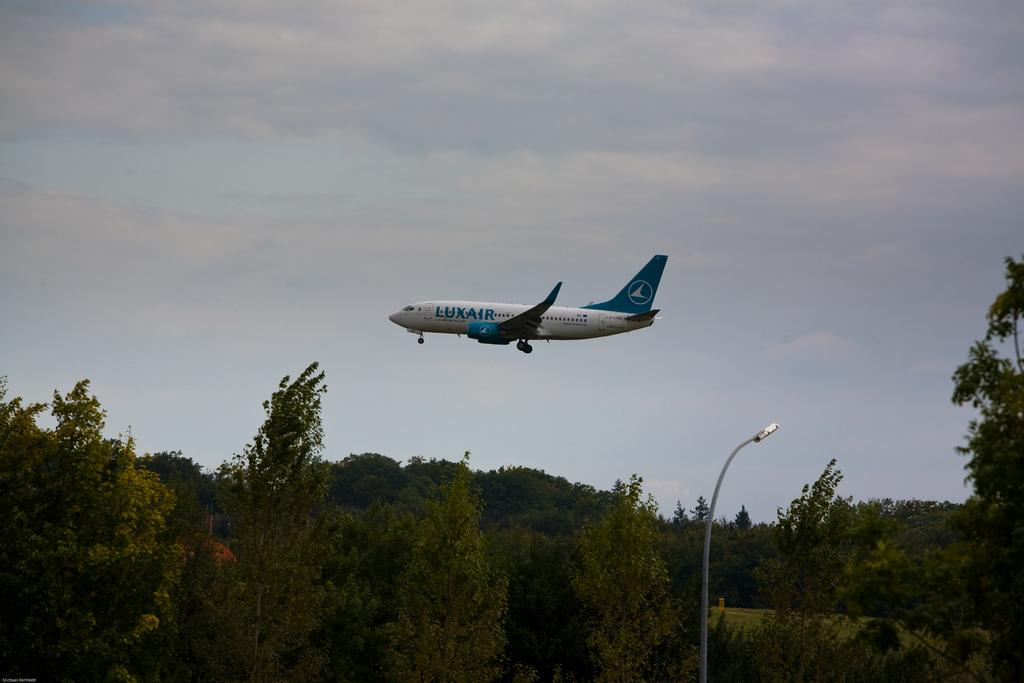Provide a one-sentence caption for the provided image. A blue and white Luxair plane is flying over the early evening sky. 